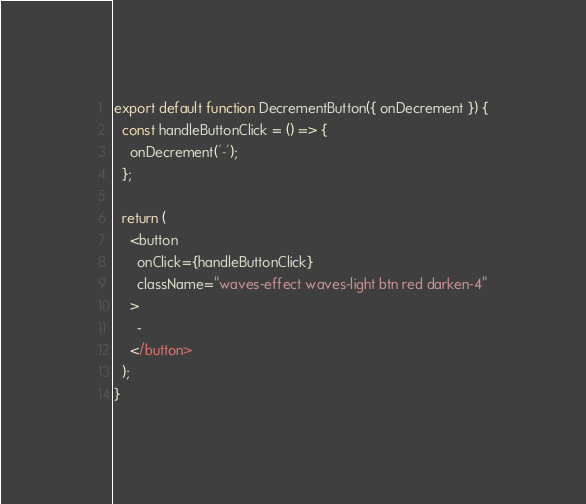Convert code to text. <code><loc_0><loc_0><loc_500><loc_500><_JavaScript_>export default function DecrementButton({ onDecrement }) {
  const handleButtonClick = () => {
    onDecrement('-');
  };

  return (
    <button
      onClick={handleButtonClick}
      className="waves-effect waves-light btn red darken-4"
    >
      -
    </button>
  );
}
</code> 